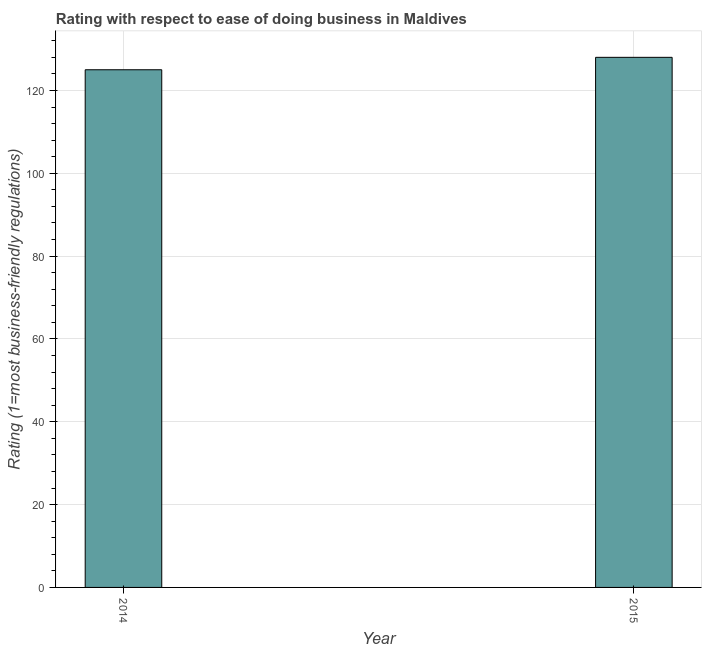Does the graph contain grids?
Your response must be concise. Yes. What is the title of the graph?
Ensure brevity in your answer.  Rating with respect to ease of doing business in Maldives. What is the label or title of the X-axis?
Keep it short and to the point. Year. What is the label or title of the Y-axis?
Ensure brevity in your answer.  Rating (1=most business-friendly regulations). What is the ease of doing business index in 2015?
Your response must be concise. 128. Across all years, what is the maximum ease of doing business index?
Offer a terse response. 128. Across all years, what is the minimum ease of doing business index?
Ensure brevity in your answer.  125. In which year was the ease of doing business index maximum?
Your answer should be compact. 2015. What is the sum of the ease of doing business index?
Ensure brevity in your answer.  253. What is the average ease of doing business index per year?
Give a very brief answer. 126. What is the median ease of doing business index?
Offer a very short reply. 126.5. What is the ratio of the ease of doing business index in 2014 to that in 2015?
Make the answer very short. 0.98. Are all the bars in the graph horizontal?
Provide a short and direct response. No. How many years are there in the graph?
Provide a short and direct response. 2. Are the values on the major ticks of Y-axis written in scientific E-notation?
Provide a succinct answer. No. What is the Rating (1=most business-friendly regulations) in 2014?
Your answer should be very brief. 125. What is the Rating (1=most business-friendly regulations) in 2015?
Keep it short and to the point. 128. 